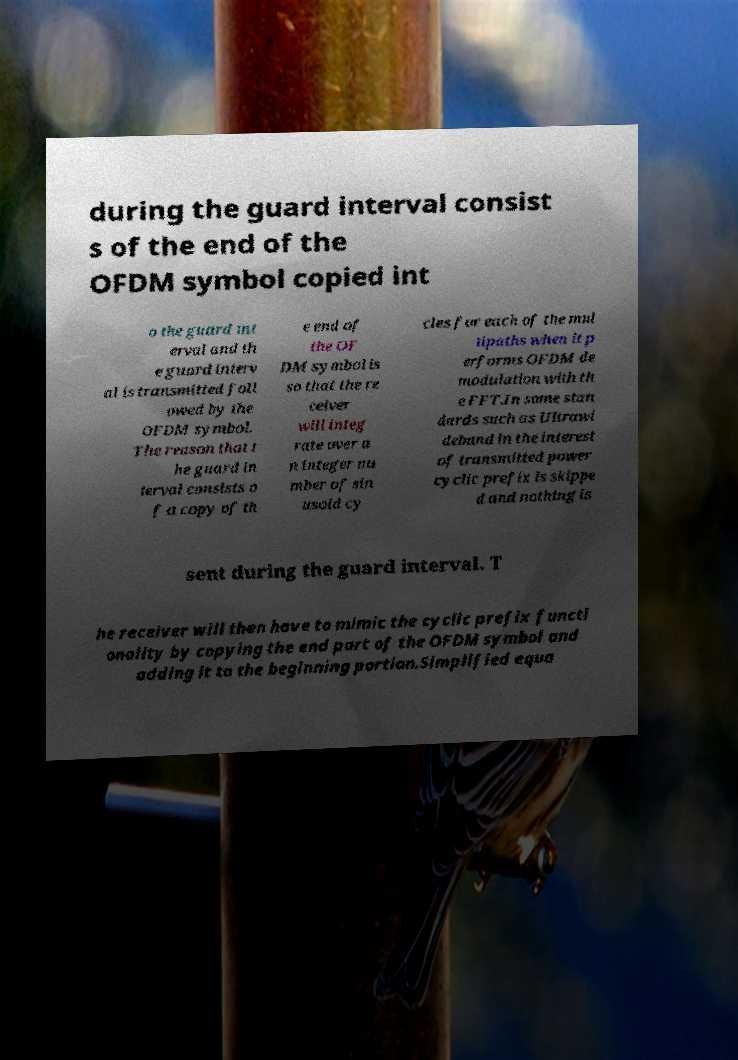Can you accurately transcribe the text from the provided image for me? during the guard interval consist s of the end of the OFDM symbol copied int o the guard int erval and th e guard interv al is transmitted foll owed by the OFDM symbol. The reason that t he guard in terval consists o f a copy of th e end of the OF DM symbol is so that the re ceiver will integ rate over a n integer nu mber of sin usoid cy cles for each of the mul tipaths when it p erforms OFDM de modulation with th e FFT.In some stan dards such as Ultrawi deband in the interest of transmitted power cyclic prefix is skippe d and nothing is sent during the guard interval. T he receiver will then have to mimic the cyclic prefix functi onality by copying the end part of the OFDM symbol and adding it to the beginning portion.Simplified equa 